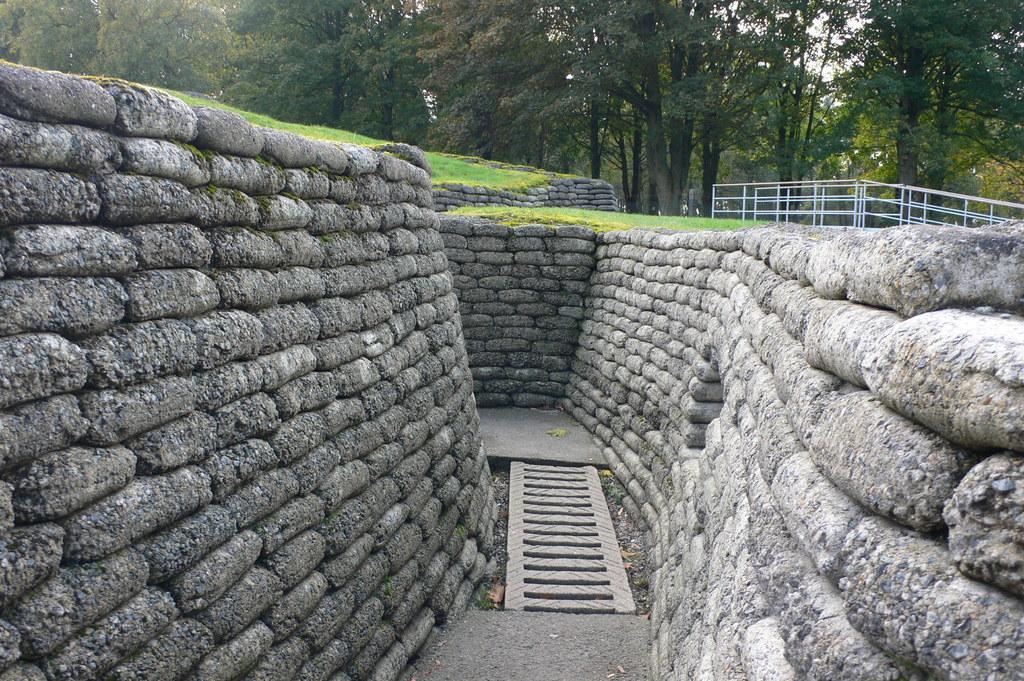Can you describe this image briefly? In this picture we can see few rocks and fence, in the background we can find grass and few trees. 